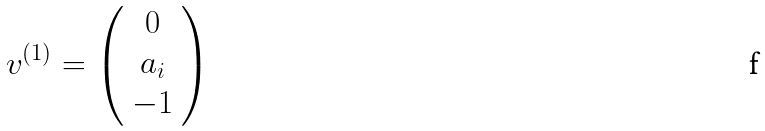Convert formula to latex. <formula><loc_0><loc_0><loc_500><loc_500>v ^ { ( 1 ) } = \left ( \begin{array} { c c c } 0 \\ a _ { i } \\ - 1 \end{array} \right )</formula> 